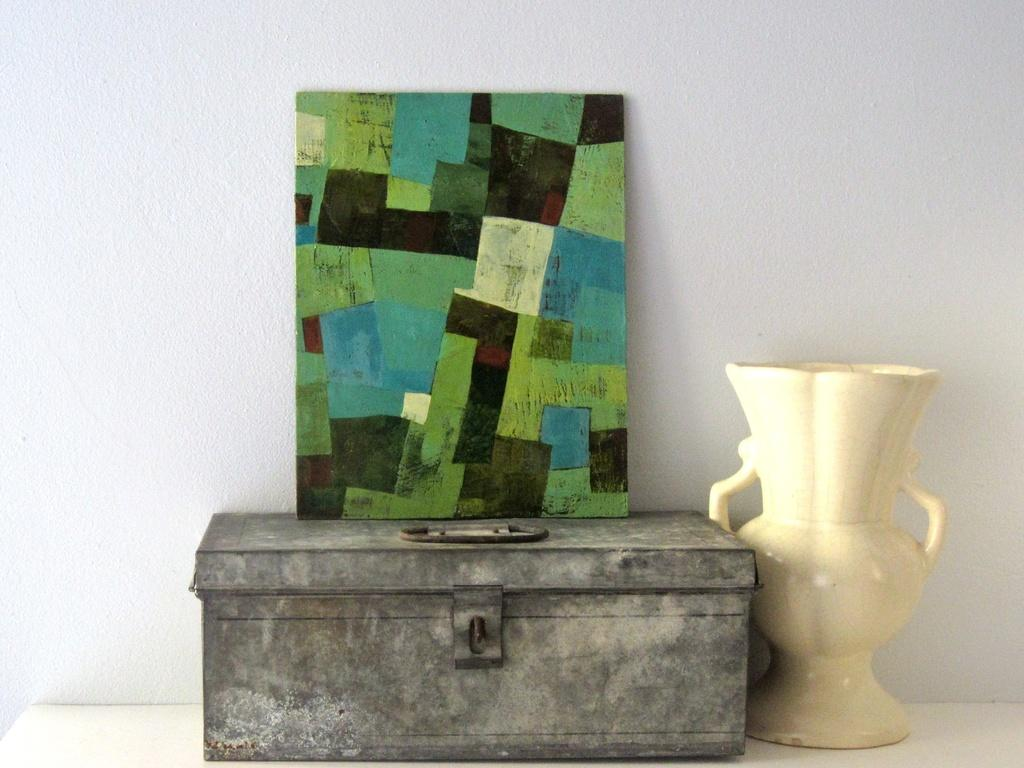What is the primary color of the surface in the image? The surface in the image is white. What object is placed on the white surface? There is a box on the white surface. What can be seen on top of the box? There is a colorful thing on the box. What is located next to the box? There is a vase next to the box. What can be seen in the background of the image? There is a wall visible in the background of the image. How many lizards are sitting on the swing in the image? There is no swing or lizards present in the image. What type of vase is on the swing in the image? There is no swing or vase on a swing in the image; the vase is located next to the box on the white surface. 